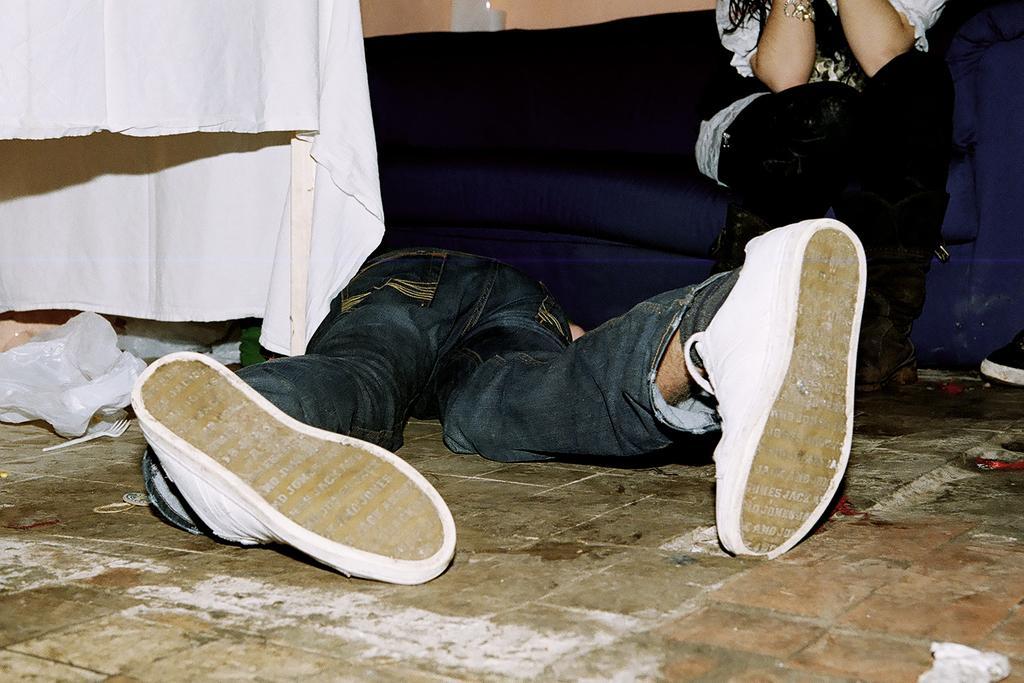Describe this image in one or two sentences. On the left there are table, cloth, cover and a fork. In the center of the picture there is a person lying. On the right there is a woman sitting on the couch. 